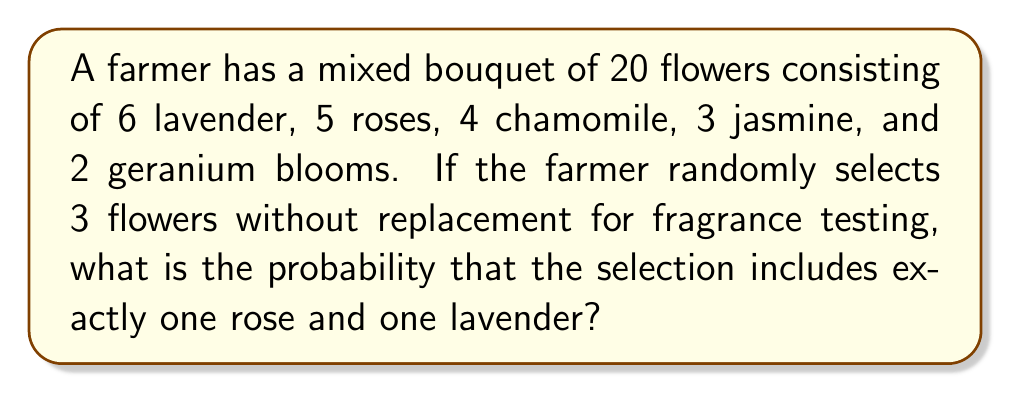Could you help me with this problem? Let's approach this step-by-step:

1) We need to calculate the probability of selecting exactly one rose, one lavender, and one of the other flowers.

2) We can use the multiplication principle of probability for independent events.

3) The probability is:

   $$P(\text{1 rose, 1 lavender, 1 other}) = P(\text{1 rose}) \times P(\text{1 lavender}) \times P(\text{1 other})$$

4) To select 1 rose out of 5 roses in 3 draws:
   $$P(\text{1 rose}) = \frac{\binom{5}{1} \times \binom{15}{2}}{\binom{20}{3}}$$

5) To select 1 lavender out of 6 lavenders in the remaining 2 draws:
   $$P(\text{1 lavender}) = \frac{\binom{6}{1}}{\binom{15}{1}}$$

6) To select 1 other flower out of the remaining 9 flowers in the last draw:
   $$P(\text{1 other}) = \frac{9}{14}$$

7) Multiplying these probabilities:

   $$P(\text{1 rose, 1 lavender, 1 other}) = \frac{\binom{5}{1} \times \binom{15}{2}}{\binom{20}{3}} \times \frac{\binom{6}{1}}{\binom{15}{1}} \times \frac{9}{14}$$

8) Simplifying:
   $$= \frac{5 \times 105}{1140} \times \frac{6}{15} \times \frac{9}{14} = \frac{1890}{79800} = \frac{63}{2660}$$

Therefore, the probability is $\frac{63}{2660}$.
Answer: $\frac{63}{2660}$ 